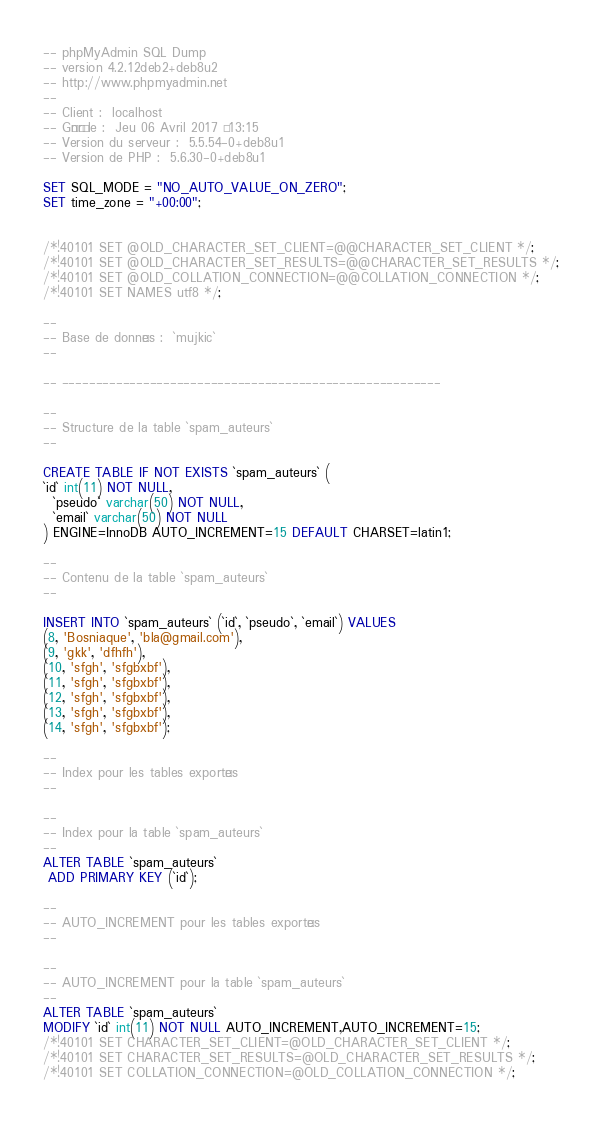Convert code to text. <code><loc_0><loc_0><loc_500><loc_500><_SQL_>-- phpMyAdmin SQL Dump
-- version 4.2.12deb2+deb8u2
-- http://www.phpmyadmin.net
--
-- Client :  localhost
-- Généré le :  Jeu 06 Avril 2017 à 13:15
-- Version du serveur :  5.5.54-0+deb8u1
-- Version de PHP :  5.6.30-0+deb8u1

SET SQL_MODE = "NO_AUTO_VALUE_ON_ZERO";
SET time_zone = "+00:00";


/*!40101 SET @OLD_CHARACTER_SET_CLIENT=@@CHARACTER_SET_CLIENT */;
/*!40101 SET @OLD_CHARACTER_SET_RESULTS=@@CHARACTER_SET_RESULTS */;
/*!40101 SET @OLD_COLLATION_CONNECTION=@@COLLATION_CONNECTION */;
/*!40101 SET NAMES utf8 */;

--
-- Base de données :  `mujkic`
--

-- --------------------------------------------------------

--
-- Structure de la table `spam_auteurs`
--

CREATE TABLE IF NOT EXISTS `spam_auteurs` (
`id` int(11) NOT NULL,
  `pseudo` varchar(50) NOT NULL,
  `email` varchar(50) NOT NULL
) ENGINE=InnoDB AUTO_INCREMENT=15 DEFAULT CHARSET=latin1;

--
-- Contenu de la table `spam_auteurs`
--

INSERT INTO `spam_auteurs` (`id`, `pseudo`, `email`) VALUES
(8, 'Bosniaque', 'bla@gmail.com'),
(9, 'gkk', 'dfhfh'),
(10, 'sfgh', 'sfgbxbf'),
(11, 'sfgh', 'sfgbxbf'),
(12, 'sfgh', 'sfgbxbf'),
(13, 'sfgh', 'sfgbxbf'),
(14, 'sfgh', 'sfgbxbf');

--
-- Index pour les tables exportées
--

--
-- Index pour la table `spam_auteurs`
--
ALTER TABLE `spam_auteurs`
 ADD PRIMARY KEY (`id`);

--
-- AUTO_INCREMENT pour les tables exportées
--

--
-- AUTO_INCREMENT pour la table `spam_auteurs`
--
ALTER TABLE `spam_auteurs`
MODIFY `id` int(11) NOT NULL AUTO_INCREMENT,AUTO_INCREMENT=15;
/*!40101 SET CHARACTER_SET_CLIENT=@OLD_CHARACTER_SET_CLIENT */;
/*!40101 SET CHARACTER_SET_RESULTS=@OLD_CHARACTER_SET_RESULTS */;
/*!40101 SET COLLATION_CONNECTION=@OLD_COLLATION_CONNECTION */;
</code> 